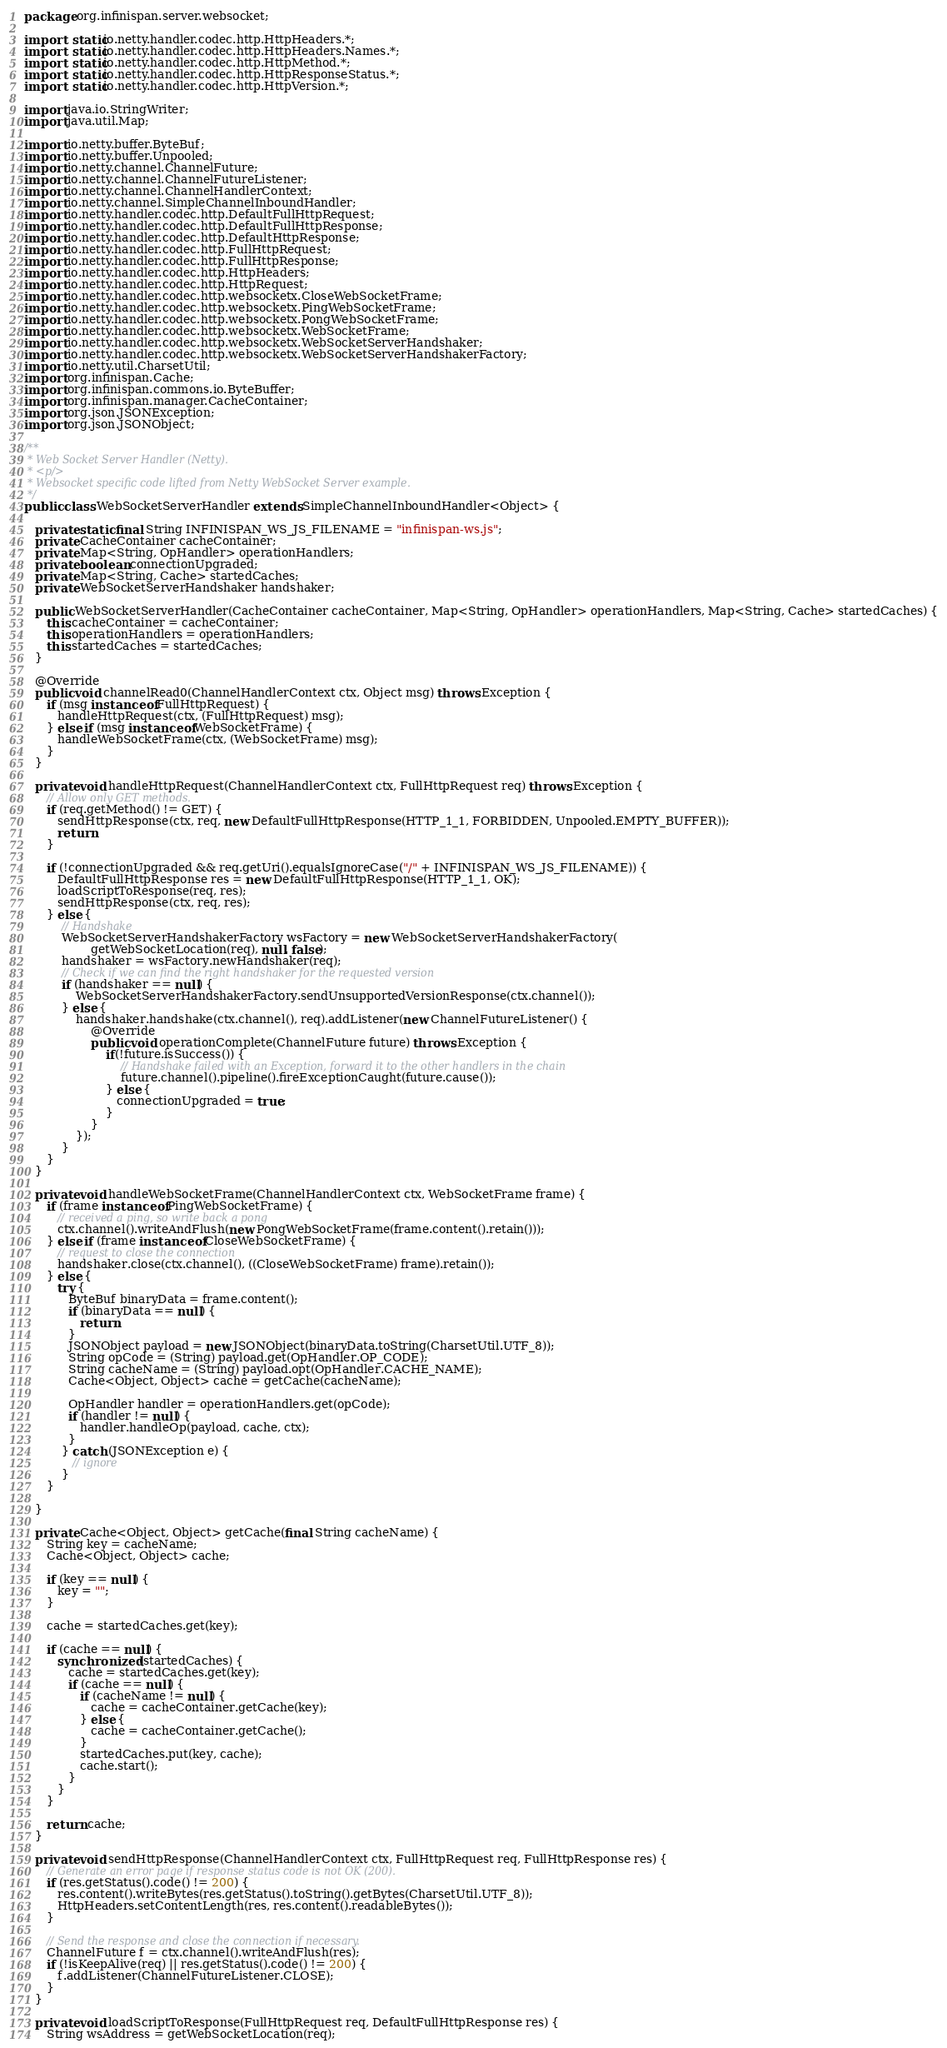<code> <loc_0><loc_0><loc_500><loc_500><_Java_>package org.infinispan.server.websocket;

import static io.netty.handler.codec.http.HttpHeaders.*;
import static io.netty.handler.codec.http.HttpHeaders.Names.*;
import static io.netty.handler.codec.http.HttpMethod.*;
import static io.netty.handler.codec.http.HttpResponseStatus.*;
import static io.netty.handler.codec.http.HttpVersion.*;

import java.io.StringWriter;
import java.util.Map;

import io.netty.buffer.ByteBuf;
import io.netty.buffer.Unpooled;
import io.netty.channel.ChannelFuture;
import io.netty.channel.ChannelFutureListener;
import io.netty.channel.ChannelHandlerContext;
import io.netty.channel.SimpleChannelInboundHandler;
import io.netty.handler.codec.http.DefaultFullHttpRequest;
import io.netty.handler.codec.http.DefaultFullHttpResponse;
import io.netty.handler.codec.http.DefaultHttpResponse;
import io.netty.handler.codec.http.FullHttpRequest;
import io.netty.handler.codec.http.FullHttpResponse;
import io.netty.handler.codec.http.HttpHeaders;
import io.netty.handler.codec.http.HttpRequest;
import io.netty.handler.codec.http.websocketx.CloseWebSocketFrame;
import io.netty.handler.codec.http.websocketx.PingWebSocketFrame;
import io.netty.handler.codec.http.websocketx.PongWebSocketFrame;
import io.netty.handler.codec.http.websocketx.WebSocketFrame;
import io.netty.handler.codec.http.websocketx.WebSocketServerHandshaker;
import io.netty.handler.codec.http.websocketx.WebSocketServerHandshakerFactory;
import io.netty.util.CharsetUtil;
import org.infinispan.Cache;
import org.infinispan.commons.io.ByteBuffer;
import org.infinispan.manager.CacheContainer;
import org.json.JSONException;
import org.json.JSONObject;

/**
 * Web Socket Server Handler (Netty).
 * <p/>
 * Websocket specific code lifted from Netty WebSocket Server example.
 */
public class WebSocketServerHandler extends SimpleChannelInboundHandler<Object> {

   private static final String INFINISPAN_WS_JS_FILENAME = "infinispan-ws.js";
   private CacheContainer cacheContainer;
   private Map<String, OpHandler> operationHandlers;
   private boolean connectionUpgraded;
   private Map<String, Cache> startedCaches;
   private WebSocketServerHandshaker handshaker;
   
   public WebSocketServerHandler(CacheContainer cacheContainer, Map<String, OpHandler> operationHandlers, Map<String, Cache> startedCaches) {
      this.cacheContainer = cacheContainer;
      this.operationHandlers = operationHandlers;
      this.startedCaches = startedCaches;
   }

   @Override
   public void channelRead0(ChannelHandlerContext ctx, Object msg) throws Exception {
      if (msg instanceof FullHttpRequest) {
         handleHttpRequest(ctx, (FullHttpRequest) msg);
      } else if (msg instanceof WebSocketFrame) {
         handleWebSocketFrame(ctx, (WebSocketFrame) msg);
      }
   }

   private void handleHttpRequest(ChannelHandlerContext ctx, FullHttpRequest req) throws Exception {
      // Allow only GET methods.
      if (req.getMethod() != GET) {
         sendHttpResponse(ctx, req, new DefaultFullHttpResponse(HTTP_1_1, FORBIDDEN, Unpooled.EMPTY_BUFFER));
         return;
      }

      if (!connectionUpgraded && req.getUri().equalsIgnoreCase("/" + INFINISPAN_WS_JS_FILENAME)) {
         DefaultFullHttpResponse res = new DefaultFullHttpResponse(HTTP_1_1, OK);
         loadScriptToResponse(req, res);
         sendHttpResponse(ctx, req, res);
      } else {
          // Handshake
          WebSocketServerHandshakerFactory wsFactory = new WebSocketServerHandshakerFactory(
                  getWebSocketLocation(req), null, false);
          handshaker = wsFactory.newHandshaker(req);
          // Check if we can find the right handshaker for the requested version
          if (handshaker == null) {
              WebSocketServerHandshakerFactory.sendUnsupportedVersionResponse(ctx.channel());
          } else {
              handshaker.handshake(ctx.channel(), req).addListener(new ChannelFutureListener() {
                  @Override
                  public void operationComplete(ChannelFuture future) throws Exception {
                      if(!future.isSuccess()) {
                          // Handshake failed with an Exception, forward it to the other handlers in the chain
                          future.channel().pipeline().fireExceptionCaught(future.cause());
                      } else {
                         connectionUpgraded = true;
                      }
                  }
              });
          }
      }
   }

   private void handleWebSocketFrame(ChannelHandlerContext ctx, WebSocketFrame frame) {
      if (frame instanceof PingWebSocketFrame) {
         // received a ping, so write back a pong
         ctx.channel().writeAndFlush(new PongWebSocketFrame(frame.content().retain()));
      } else if (frame instanceof CloseWebSocketFrame) {
         // request to close the connection
         handshaker.close(ctx.channel(), ((CloseWebSocketFrame) frame).retain());
      } else {
         try {
            ByteBuf binaryData = frame.content();
            if (binaryData == null) {
               return;
            }
            JSONObject payload = new JSONObject(binaryData.toString(CharsetUtil.UTF_8));
            String opCode = (String) payload.get(OpHandler.OP_CODE);
            String cacheName = (String) payload.opt(OpHandler.CACHE_NAME);
            Cache<Object, Object> cache = getCache(cacheName);
            
            OpHandler handler = operationHandlers.get(opCode);
            if (handler != null) {
               handler.handleOp(payload, cache, ctx);
            }
          } catch (JSONException e) {
             // ignore
          }
      }
      
   }

   private Cache<Object, Object> getCache(final String cacheName) {
      String key = cacheName;
      Cache<Object, Object> cache;

      if (key == null) {
         key = "";
      }

      cache = startedCaches.get(key);

      if (cache == null) {
         synchronized (startedCaches) {
            cache = startedCaches.get(key);
            if (cache == null) {
               if (cacheName != null) {
                  cache = cacheContainer.getCache(key);
               } else {
                  cache = cacheContainer.getCache();
               }
               startedCaches.put(key, cache);
               cache.start();
            }
         }
      }

      return cache;
   }

   private void sendHttpResponse(ChannelHandlerContext ctx, FullHttpRequest req, FullHttpResponse res) {
      // Generate an error page if response status code is not OK (200).
      if (res.getStatus().code() != 200) {
         res.content().writeBytes(res.getStatus().toString().getBytes(CharsetUtil.UTF_8));
         HttpHeaders.setContentLength(res, res.content().readableBytes());
      }

      // Send the response and close the connection if necessary.
      ChannelFuture f = ctx.channel().writeAndFlush(res);
      if (!isKeepAlive(req) || res.getStatus().code() != 200) {
         f.addListener(ChannelFutureListener.CLOSE);
      }
   }

   private void loadScriptToResponse(FullHttpRequest req, DefaultFullHttpResponse res) {
      String wsAddress = getWebSocketLocation(req);
</code> 